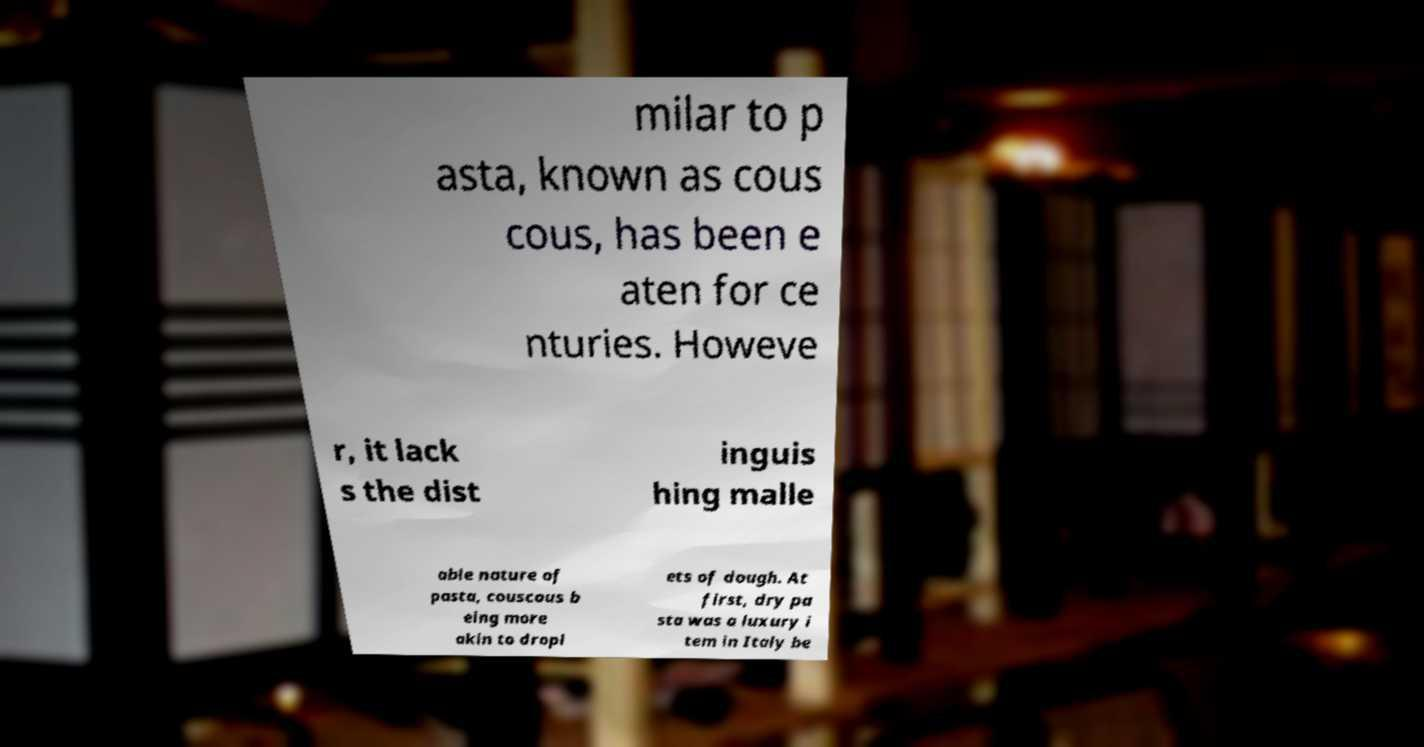Please read and relay the text visible in this image. What does it say? milar to p asta, known as cous cous, has been e aten for ce nturies. Howeve r, it lack s the dist inguis hing malle able nature of pasta, couscous b eing more akin to dropl ets of dough. At first, dry pa sta was a luxury i tem in Italy be 